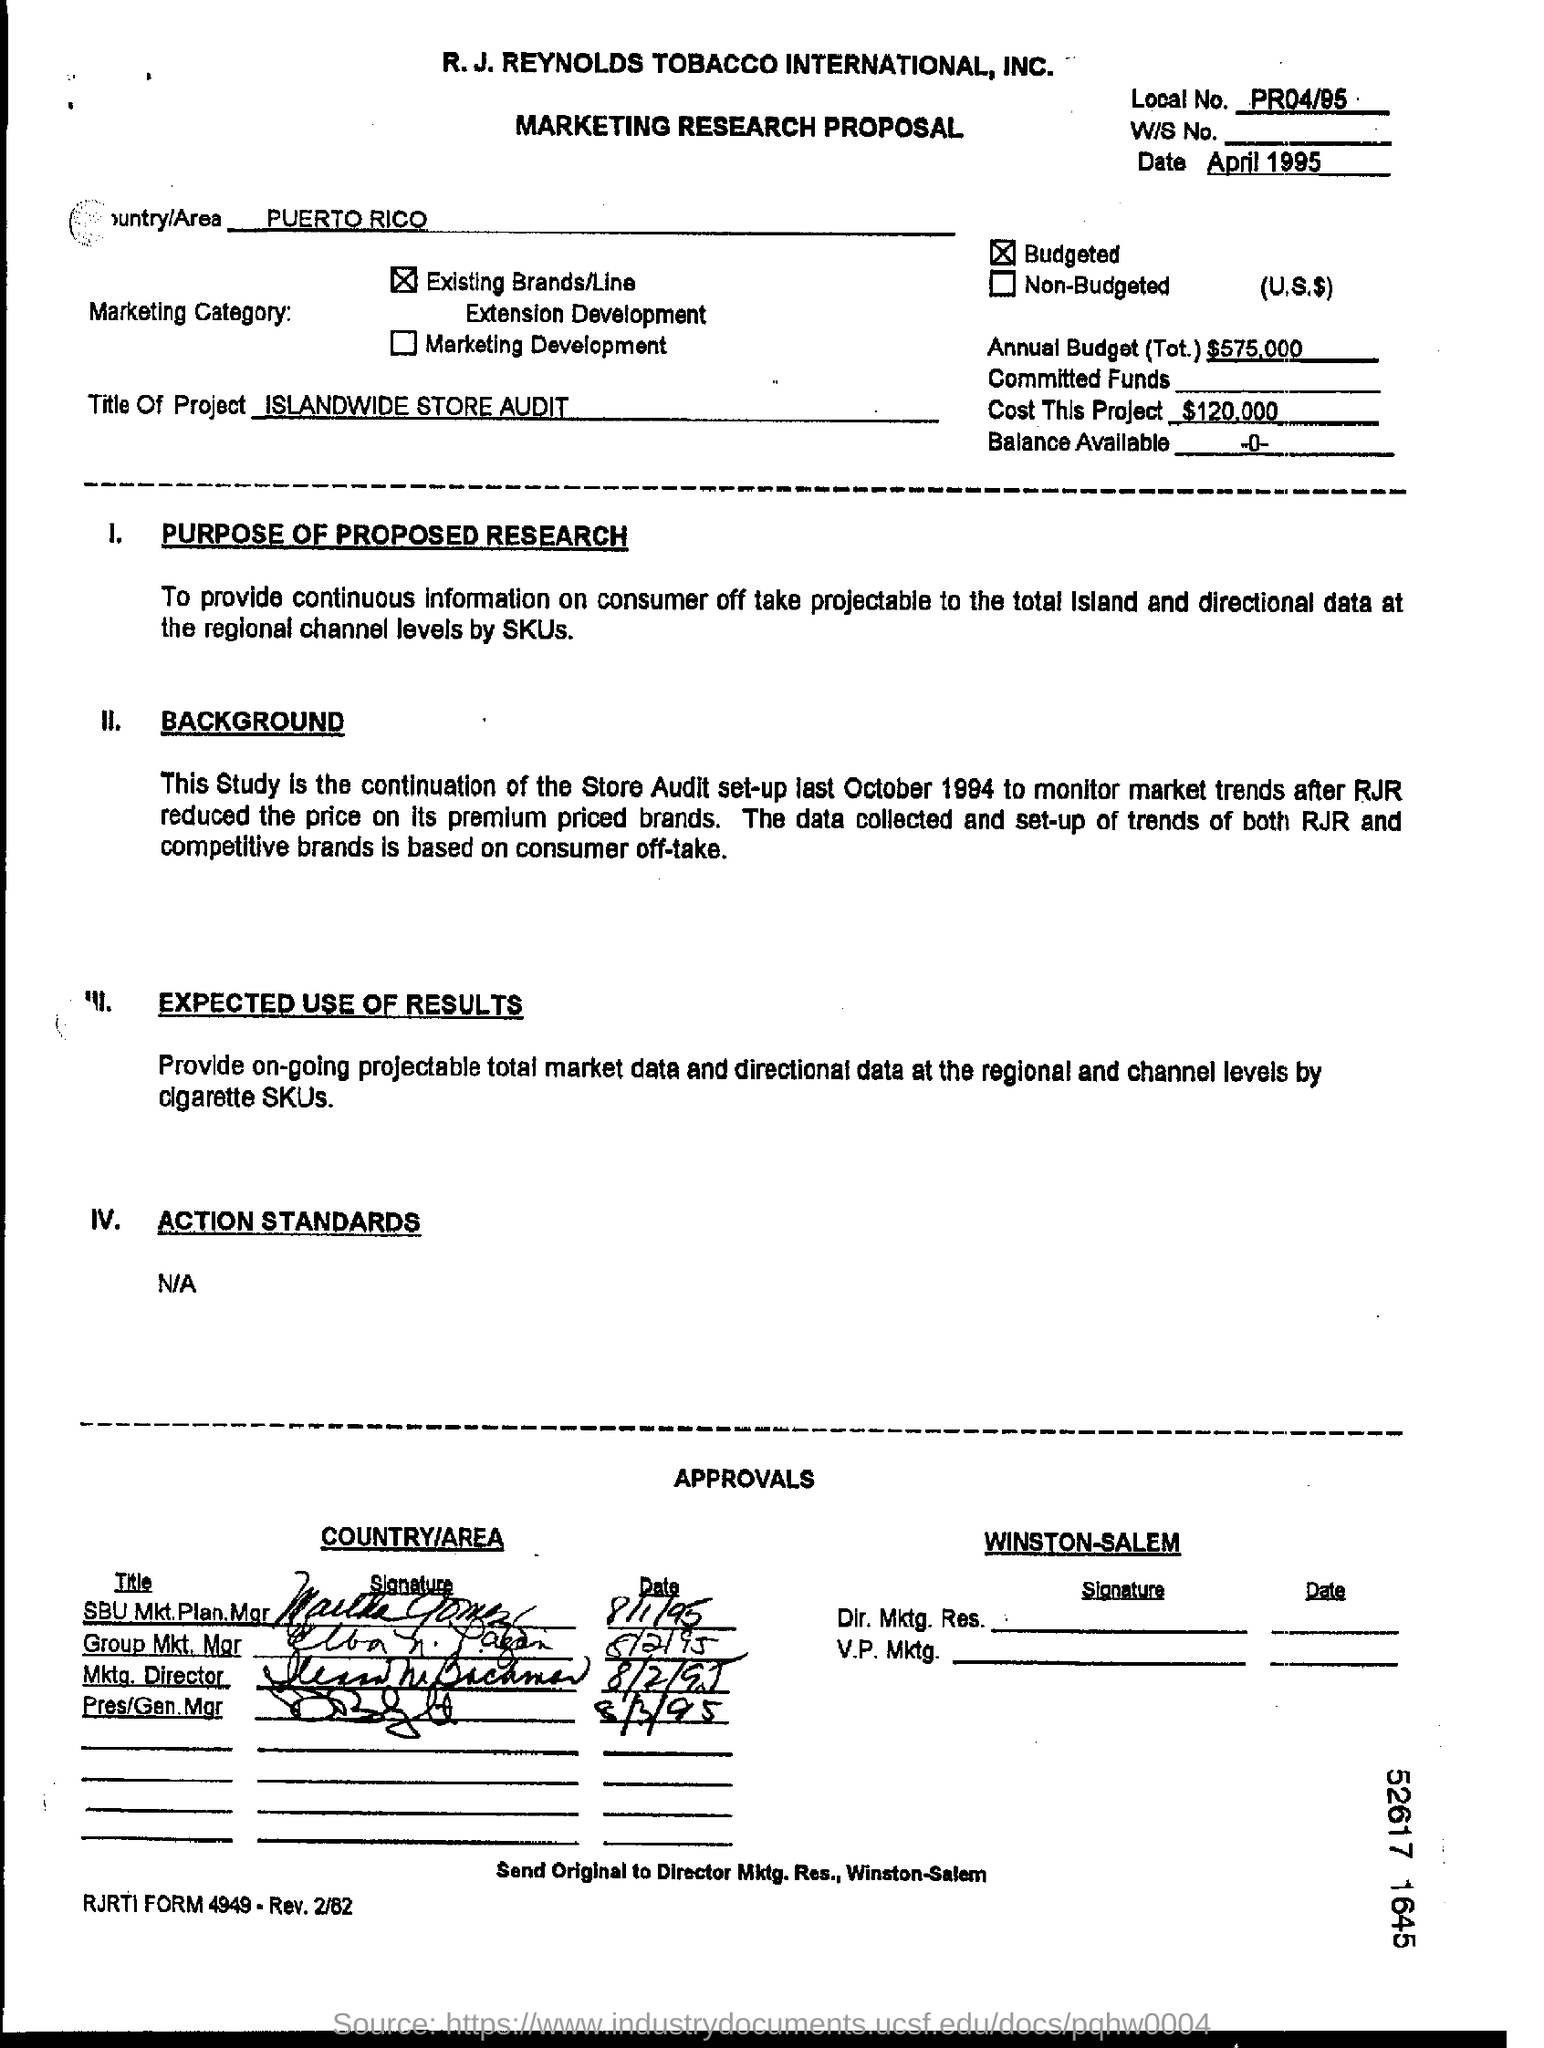Mention a couple of crucial points in this snapshot. The proposal was dated April 1995. The total cost of the project is estimated to be $120,000. The annual budget for the project is $575,000. The name of the country or area is Puerto Rico. 